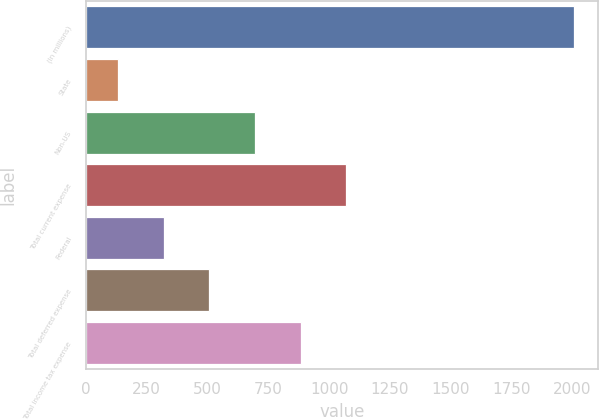<chart> <loc_0><loc_0><loc_500><loc_500><bar_chart><fcel>(In millions)<fcel>State<fcel>Non-US<fcel>Total current expense<fcel>Federal<fcel>Total deferred expense<fcel>Total income tax expense<nl><fcel>2007<fcel>133<fcel>695.2<fcel>1070<fcel>320.4<fcel>507.8<fcel>882.6<nl></chart> 